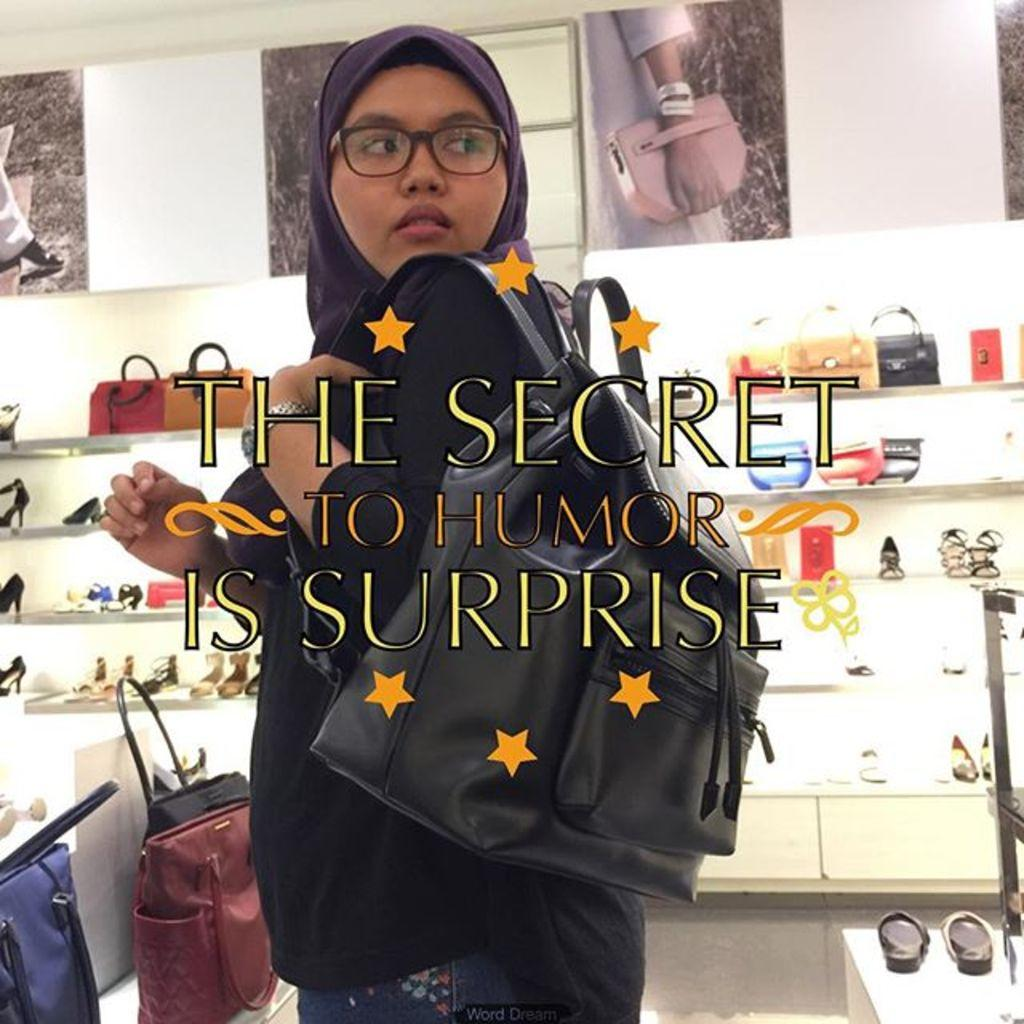Who is present in the image? There is a woman in the image. What is the woman carrying? The woman is carrying a bag. What accessory is the woman wearing? The woman is wearing glasses (specs). What can be seen in the background of the image? In the background of the image, there are multiple sandals and multiple handbags. What channel does the woman watch to get her daily dose of thrill? There is no information about the woman watching television or seeking thrills in the image. 